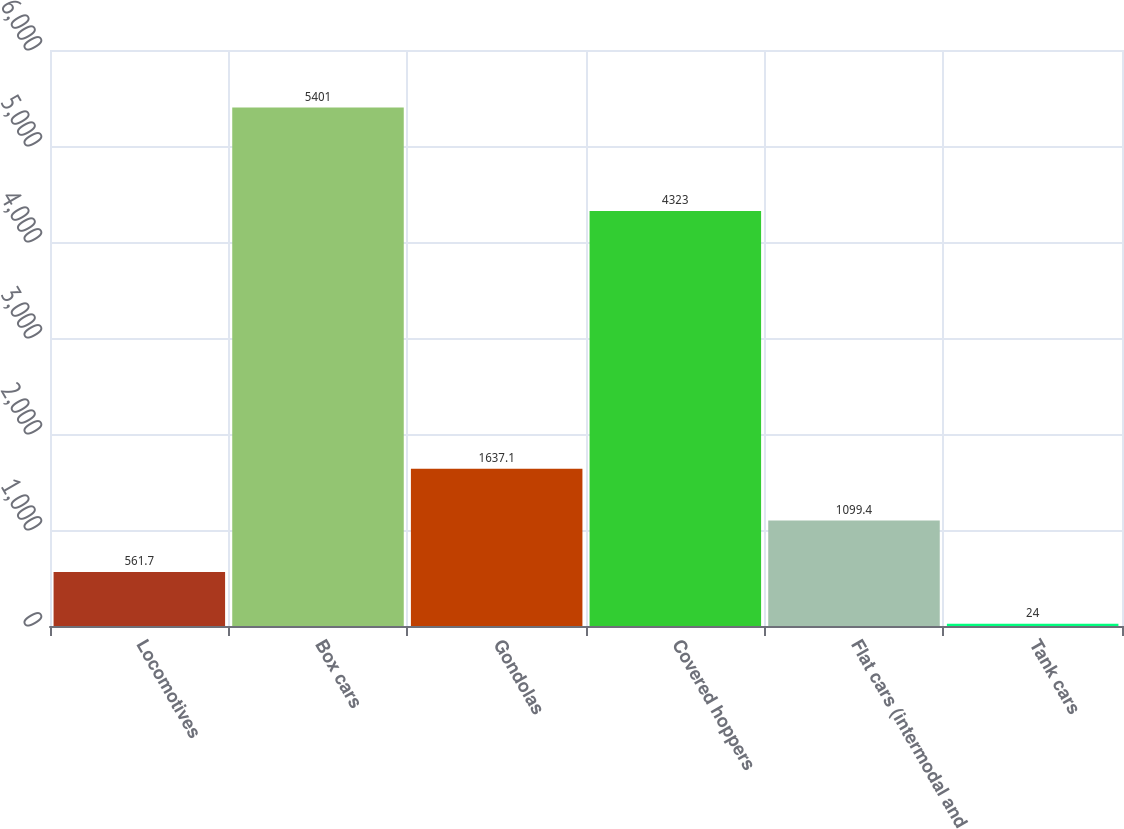Convert chart to OTSL. <chart><loc_0><loc_0><loc_500><loc_500><bar_chart><fcel>Locomotives<fcel>Box cars<fcel>Gondolas<fcel>Covered hoppers<fcel>Flat cars (intermodal and<fcel>Tank cars<nl><fcel>561.7<fcel>5401<fcel>1637.1<fcel>4323<fcel>1099.4<fcel>24<nl></chart> 